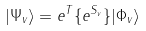Convert formula to latex. <formula><loc_0><loc_0><loc_500><loc_500>| \Psi _ { v } \rangle = e ^ { T } \{ e ^ { S _ { v } } \} | \Phi _ { v } \rangle</formula> 